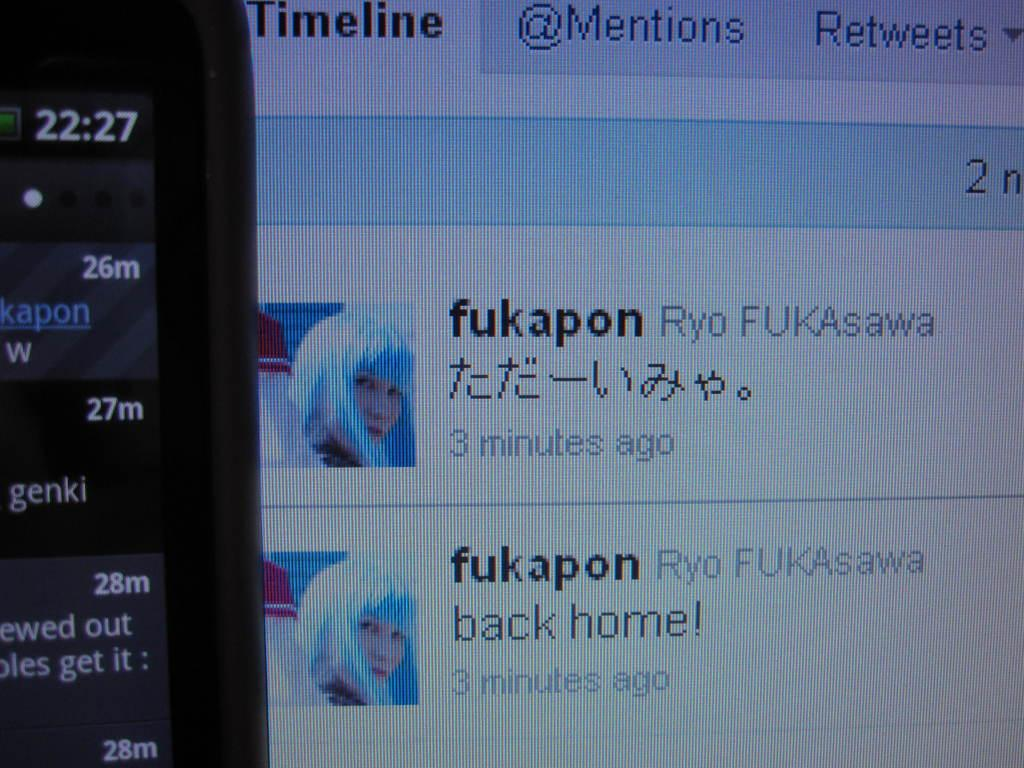What type of screen is shown in the image? The image contains a screenshot of a Twitter screen. What can be found on the Twitter screen? There is information on the Twitter screen. What is located on the left side of the image? There is a mobile screenshot on the left side of the image. What can be read on the mobile screenshot? There is text visible on the mobile screenshot. What type of pump is visible in the image? There is no pump present in the image. How old is the son in the image? There is no son present in the image. Can you see a bat flying in the image? There is no bat visible in the image. 